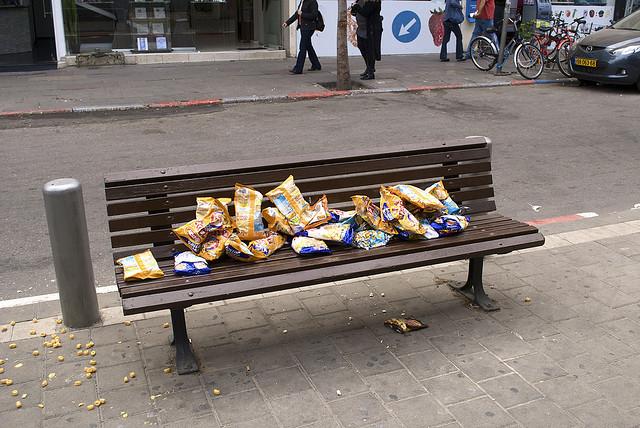What is on the bench?
Answer briefly. Snacks. What is the arrow on the wall pointing to?
Give a very brief answer. Ground. How many cars are in the background?
Concise answer only. 1. 